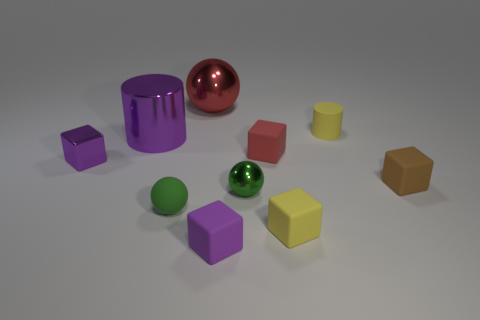Subtract all tiny spheres. How many spheres are left? 1 Subtract all spheres. How many objects are left? 7 Subtract 2 cylinders. How many cylinders are left? 0 Subtract all red balls. How many balls are left? 2 Subtract all blue spheres. How many purple cylinders are left? 1 Subtract all big brown metal objects. Subtract all large purple things. How many objects are left? 9 Add 8 tiny purple matte objects. How many tiny purple matte objects are left? 9 Add 8 tiny green objects. How many tiny green objects exist? 10 Subtract 1 yellow blocks. How many objects are left? 9 Subtract all gray cylinders. Subtract all yellow blocks. How many cylinders are left? 2 